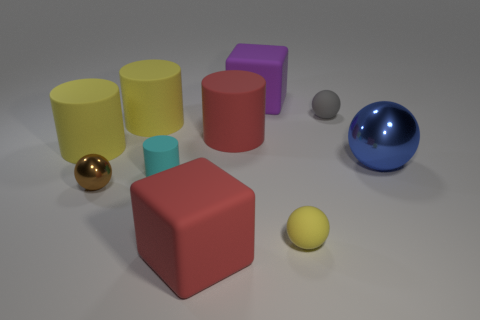How many other things are there of the same shape as the gray thing?
Make the answer very short. 3. What size is the ball that is behind the big red cylinder?
Make the answer very short. Small. How many big red blocks are in front of the large matte cube that is behind the large metal thing?
Offer a very short reply. 1. What number of other objects are there of the same size as the brown metallic object?
Give a very brief answer. 3. Do the small cylinder and the tiny metal ball have the same color?
Provide a short and direct response. No. Do the large red object that is behind the small cyan rubber object and the cyan matte object have the same shape?
Offer a very short reply. Yes. What number of spheres are both in front of the big blue metallic ball and to the right of the small gray object?
Give a very brief answer. 0. What material is the red cube?
Keep it short and to the point. Rubber. Is there any other thing of the same color as the tiny cylinder?
Provide a succinct answer. No. Is the material of the cyan thing the same as the blue ball?
Offer a terse response. No. 